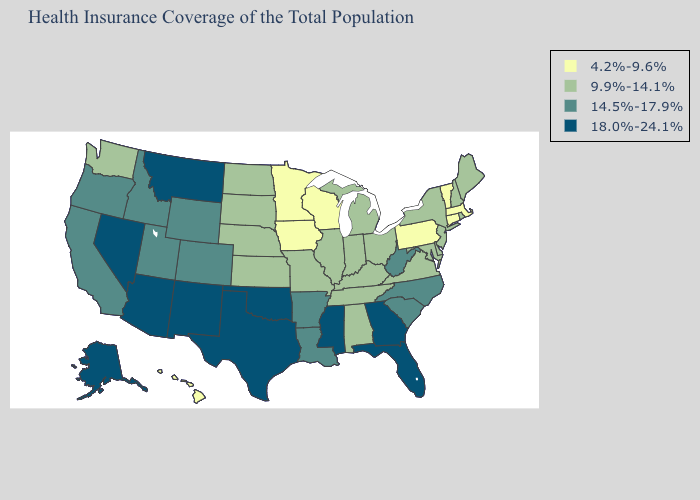What is the value of Kentucky?
Answer briefly. 9.9%-14.1%. Name the states that have a value in the range 4.2%-9.6%?
Be succinct. Connecticut, Hawaii, Iowa, Massachusetts, Minnesota, Pennsylvania, Vermont, Wisconsin. Name the states that have a value in the range 9.9%-14.1%?
Be succinct. Alabama, Delaware, Illinois, Indiana, Kansas, Kentucky, Maine, Maryland, Michigan, Missouri, Nebraska, New Hampshire, New Jersey, New York, North Dakota, Ohio, Rhode Island, South Dakota, Tennessee, Virginia, Washington. Does Massachusetts have the lowest value in the USA?
Write a very short answer. Yes. Name the states that have a value in the range 18.0%-24.1%?
Give a very brief answer. Alaska, Arizona, Florida, Georgia, Mississippi, Montana, Nevada, New Mexico, Oklahoma, Texas. Does Nevada have the same value as Kansas?
Give a very brief answer. No. Name the states that have a value in the range 14.5%-17.9%?
Answer briefly. Arkansas, California, Colorado, Idaho, Louisiana, North Carolina, Oregon, South Carolina, Utah, West Virginia, Wyoming. How many symbols are there in the legend?
Be succinct. 4. What is the value of Maryland?
Be succinct. 9.9%-14.1%. What is the highest value in the MidWest ?
Concise answer only. 9.9%-14.1%. Does California have the same value as Iowa?
Concise answer only. No. Does Connecticut have the lowest value in the USA?
Be succinct. Yes. Name the states that have a value in the range 14.5%-17.9%?
Short answer required. Arkansas, California, Colorado, Idaho, Louisiana, North Carolina, Oregon, South Carolina, Utah, West Virginia, Wyoming. Name the states that have a value in the range 4.2%-9.6%?
Keep it brief. Connecticut, Hawaii, Iowa, Massachusetts, Minnesota, Pennsylvania, Vermont, Wisconsin. Does Florida have the highest value in the USA?
Quick response, please. Yes. 